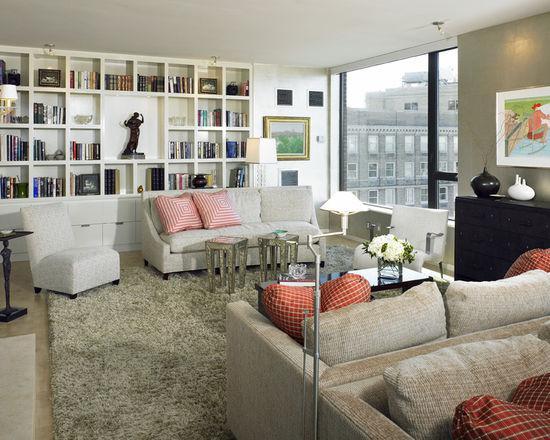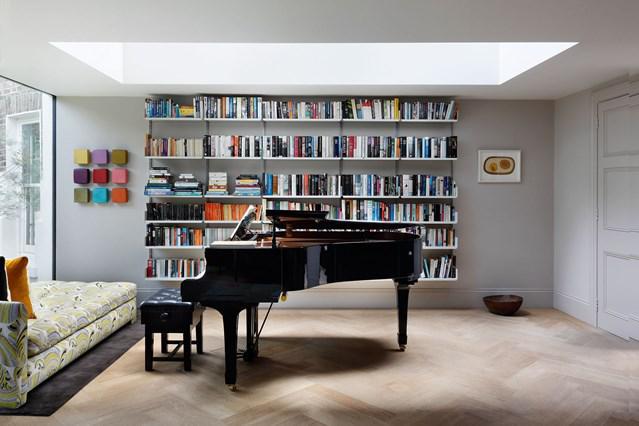The first image is the image on the left, the second image is the image on the right. Considering the images on both sides, is "In one image, a seating area is in front of an interior doorway that is surrounded by bookcases." valid? Answer yes or no. No. The first image is the image on the left, the second image is the image on the right. For the images shown, is this caption "In at least one image the white bookshelf has squaded shelves." true? Answer yes or no. Yes. 